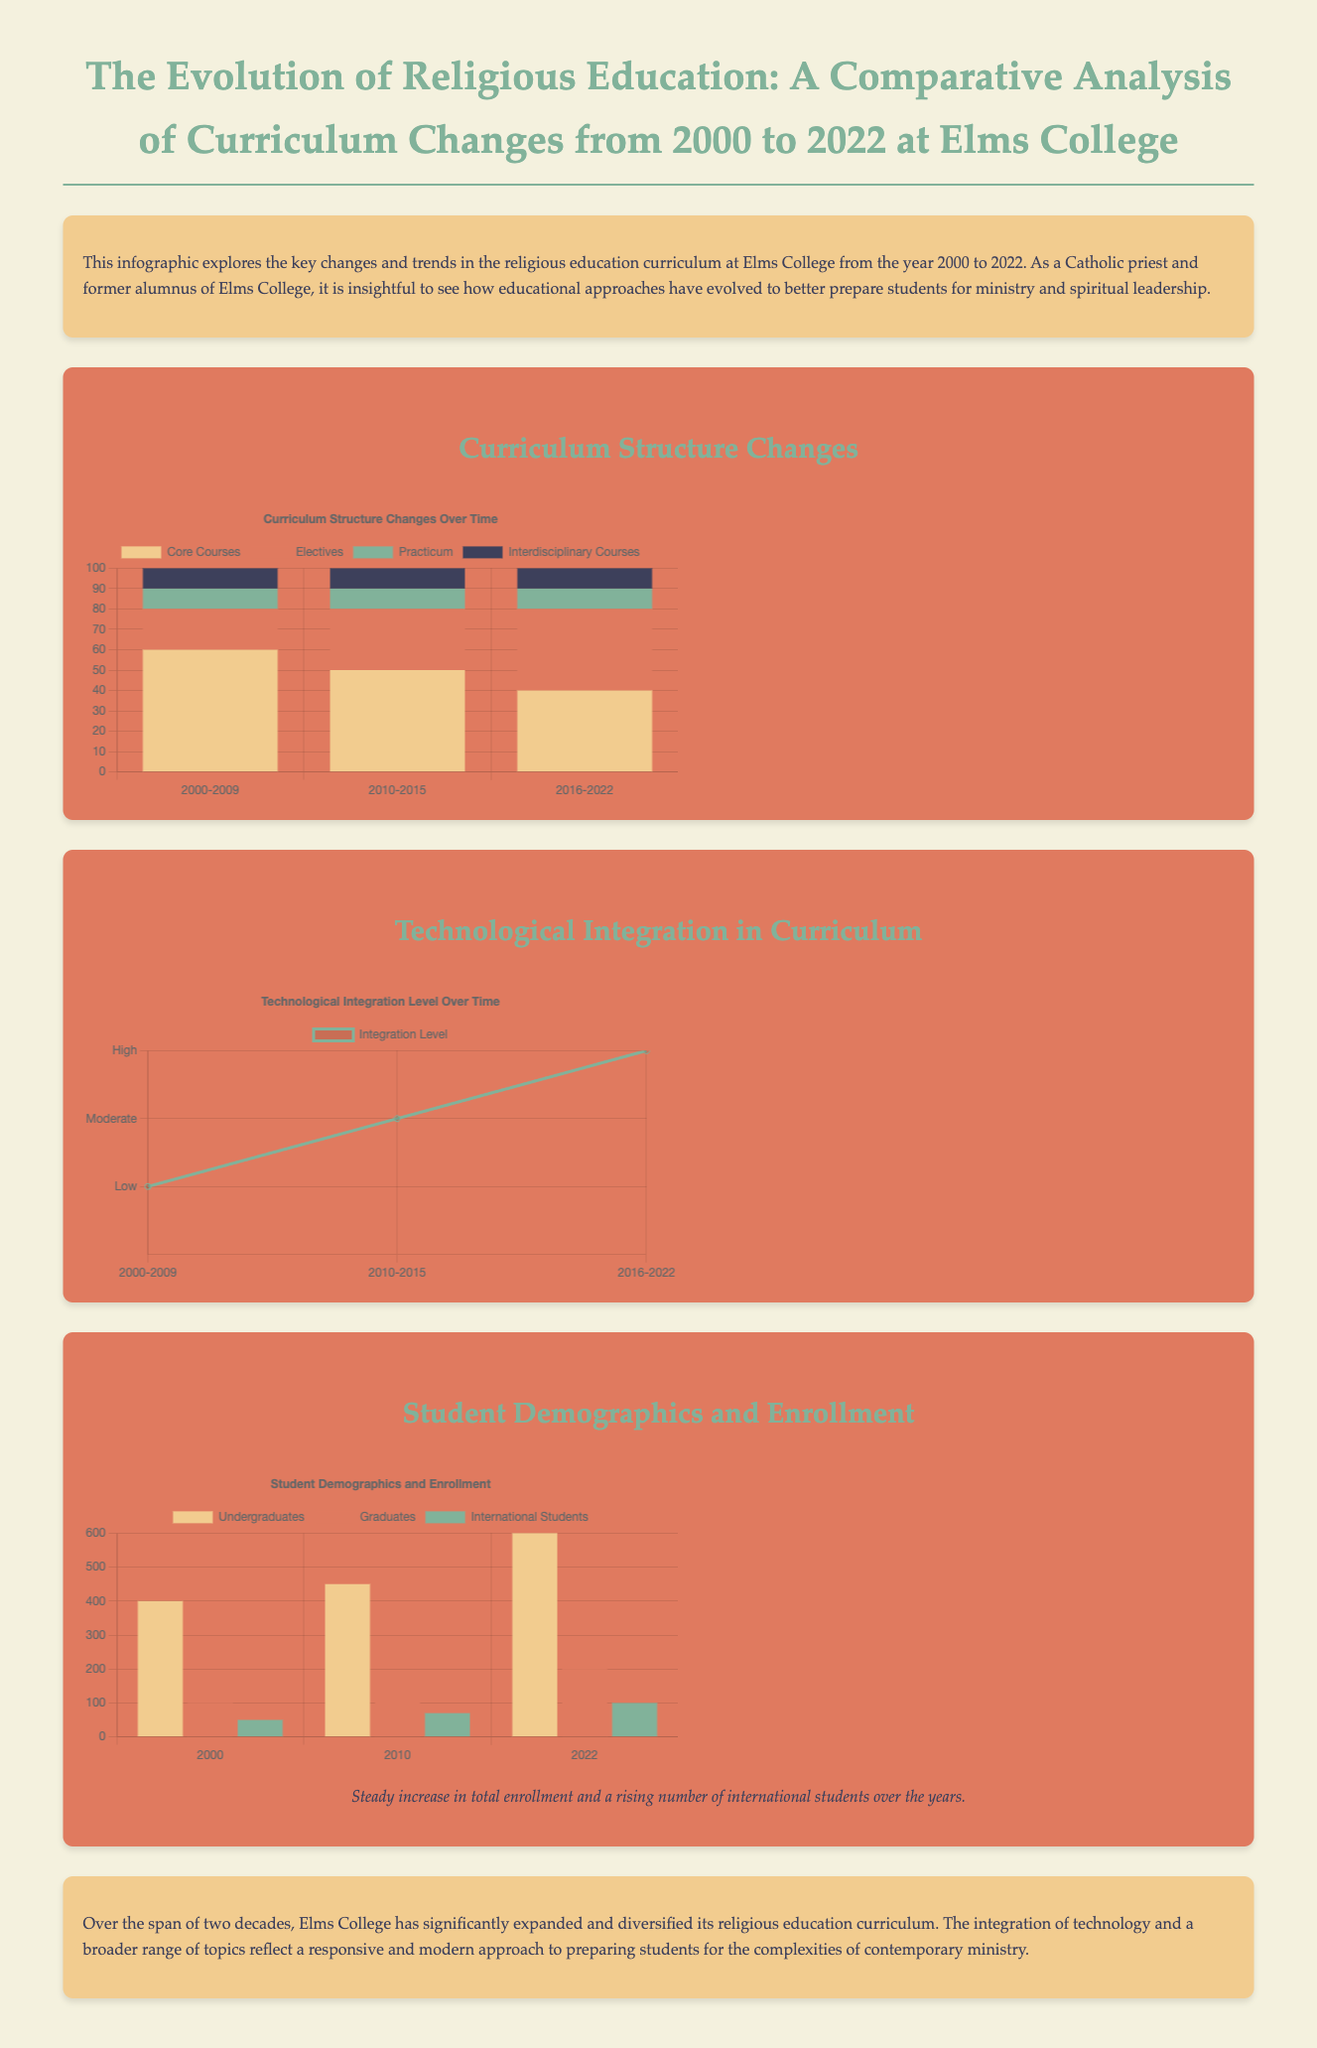What is the title of the infographic? The title summarizes the main subject of the infographic, highlighting the focus on curriculum changes in religious education at Elms College.
Answer: The Evolution of Religious Education: A Comparative Analysis of Curriculum Changes from 2000 to 2022 at Elms College In which year did the total enrollment show the highest number of undergraduates? This question seeks to identify the year with the greatest enrollment of undergraduate students as depicted in the charts.
Answer: 2022 What were the integration levels of technology in the curriculum in 2010-2015? This question refers to the specific data point for technological integration from the line chart presented.
Answer: 2 How many core courses were there in the curriculum structure from 2000-2009? The number of core courses is specified in the bar chart, showing the data related to curriculum structure.
Answer: 60 Which demographic showed a steady increase alongside total enrollment? This question requires understanding both demographic data and the trends in the charts presented for enrollment.
Answer: International Students What is the main trend observed in the curriculum structure from 2000 to 2022? This question looks for a general observation derived from the bar chart comparing curriculum structure over time.
Answer: Decrease in Core Courses What type of data visualization is used to depict technological integration levels? This asks about the specific kind of chart employed in showcasing the level of technological integration.
Answer: Line Chart Which year corresponds to the lowest number of graduate students enrolled? This question identifies the year with the lowest enrollment from the demographic data given in the bar chart.
Answer: 2000 What color represents electives in the curriculum structure chart? This question seeks a specific detail regarding the color coding used in the bar chart for better understanding.
Answer: Orange 